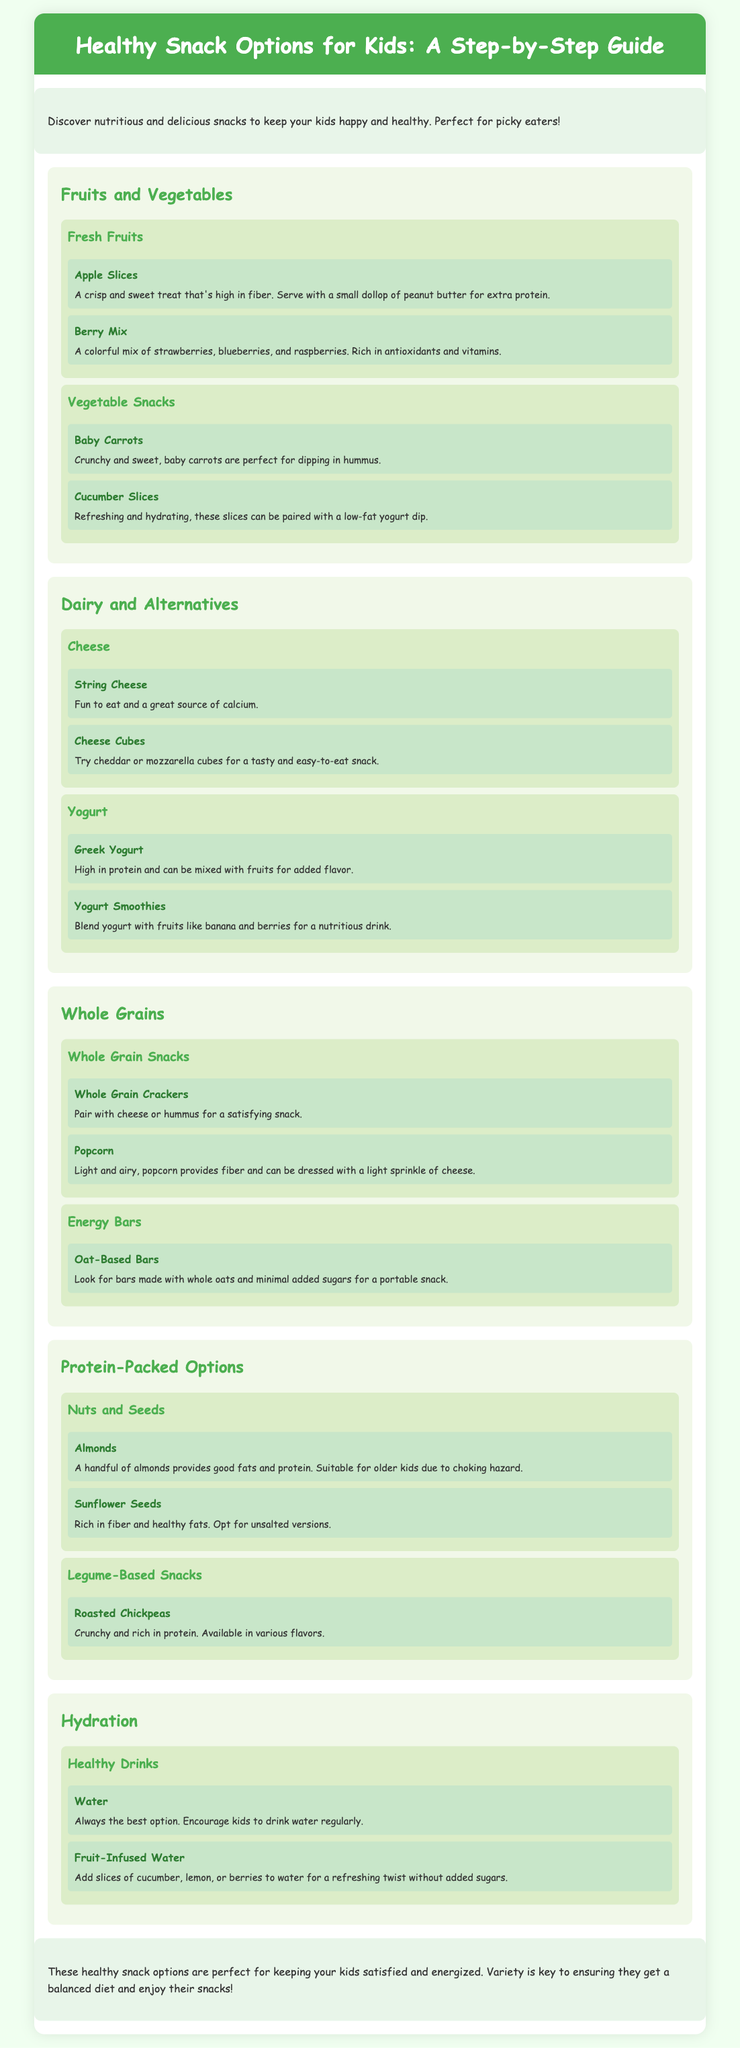what is the title of the document? The title is prominently displayed at the top of the document and provides a clear overview of the content.
Answer: Healthy Snack Options for Kids: A Step-by-Step Guide how many sections are there in the document? The document is divided into several main sections, each covering different snack options for kids.
Answer: 5 what are two examples of fresh fruits mentioned? The document lists different types of fruits in the section about fruits and vegetables, giving specific examples.
Answer: Apple Slices, Berry Mix which snack is suggested for hydration? The document identifies different snacks and drinks in the hydration section that are suitable for kids.
Answer: Water what type of cheese is fun to eat? The document provides specific examples of cheese options in the dairy section, focusing on snacks kids enjoy.
Answer: String Cheese how are baby carrots best enjoyed? The document describes the suggested way to enjoy baby carrots in the vegetable snacks subsection.
Answer: Dipping in hummus which snack option is rich in protein and can be flavored? The document highlights nutritious snacks and suggests an option that is protein-rich and available in various flavors.
Answer: Roasted Chickpeas what should be added to water for a refreshing twist? The document mentions adding specific items to water in the hydration section, offering a creative drink option for kids.
Answer: Slices of cucumber, lemon, or berries 